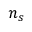<formula> <loc_0><loc_0><loc_500><loc_500>{ n _ { s } }</formula> 